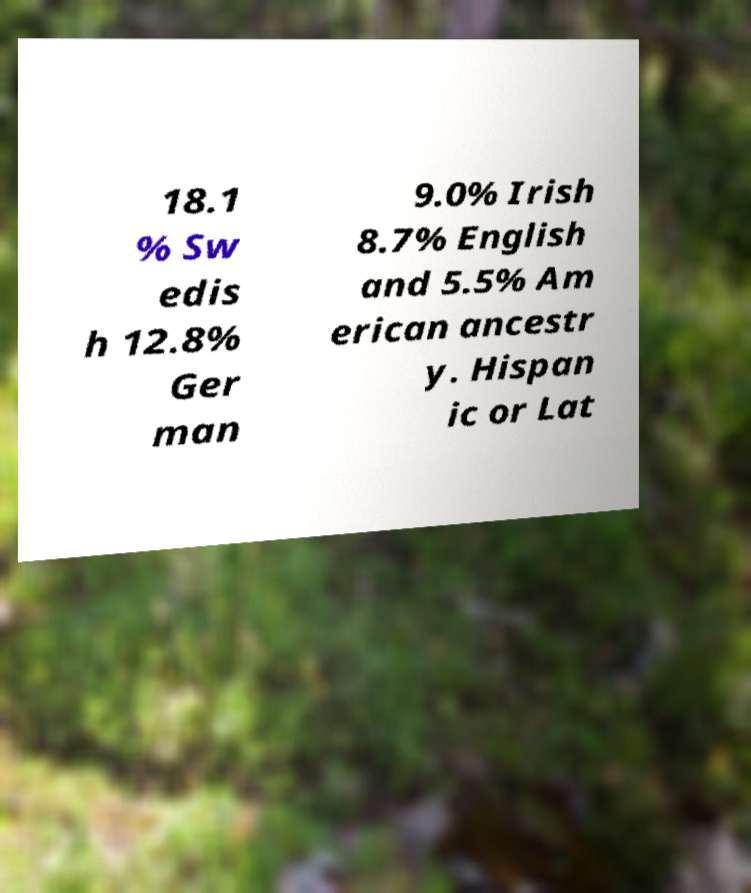Please read and relay the text visible in this image. What does it say? 18.1 % Sw edis h 12.8% Ger man 9.0% Irish 8.7% English and 5.5% Am erican ancestr y. Hispan ic or Lat 